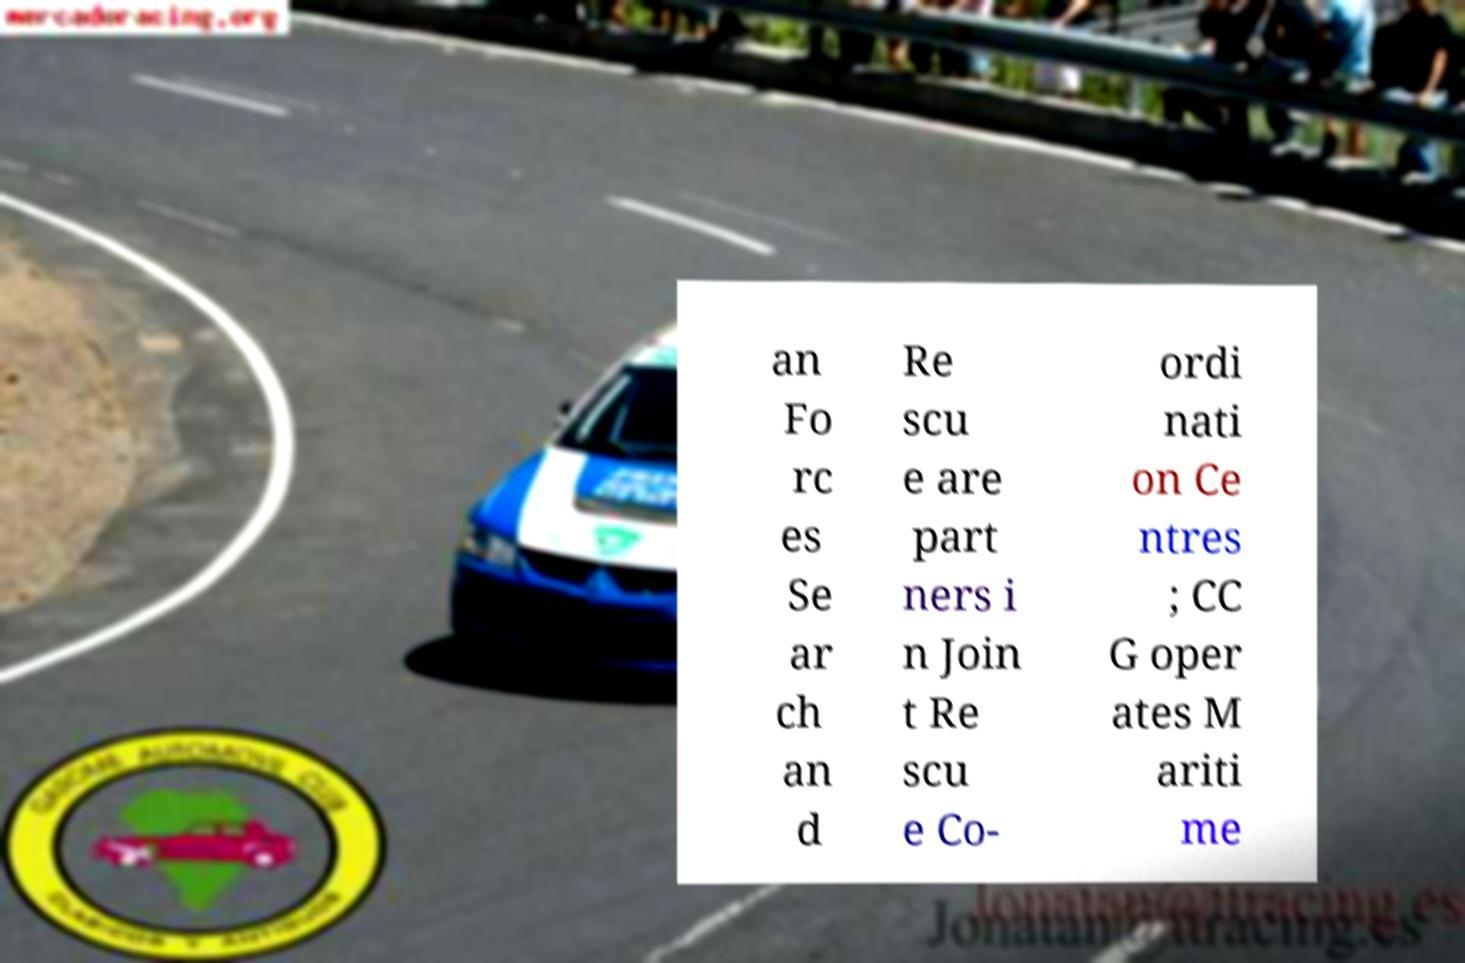Please read and relay the text visible in this image. What does it say? an Fo rc es Se ar ch an d Re scu e are part ners i n Join t Re scu e Co- ordi nati on Ce ntres ; CC G oper ates M ariti me 